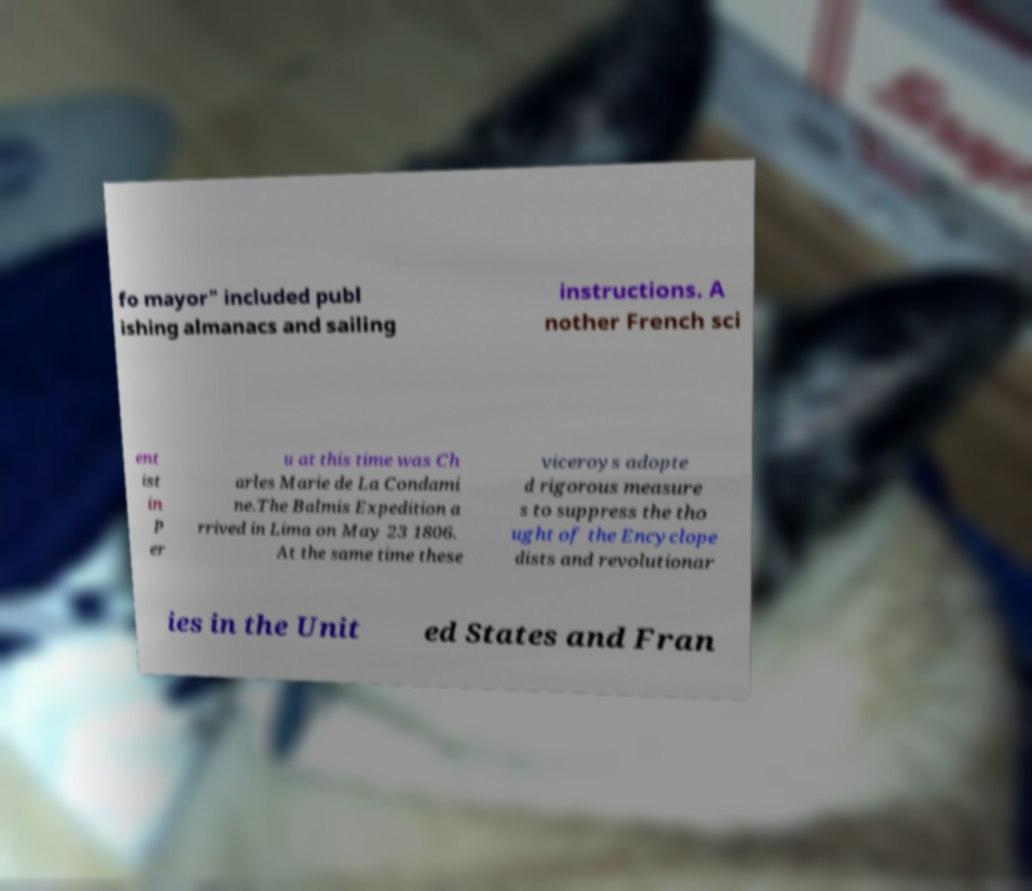Can you accurately transcribe the text from the provided image for me? fo mayor" included publ ishing almanacs and sailing instructions. A nother French sci ent ist in P er u at this time was Ch arles Marie de La Condami ne.The Balmis Expedition a rrived in Lima on May 23 1806. At the same time these viceroys adopte d rigorous measure s to suppress the tho ught of the Encyclope dists and revolutionar ies in the Unit ed States and Fran 